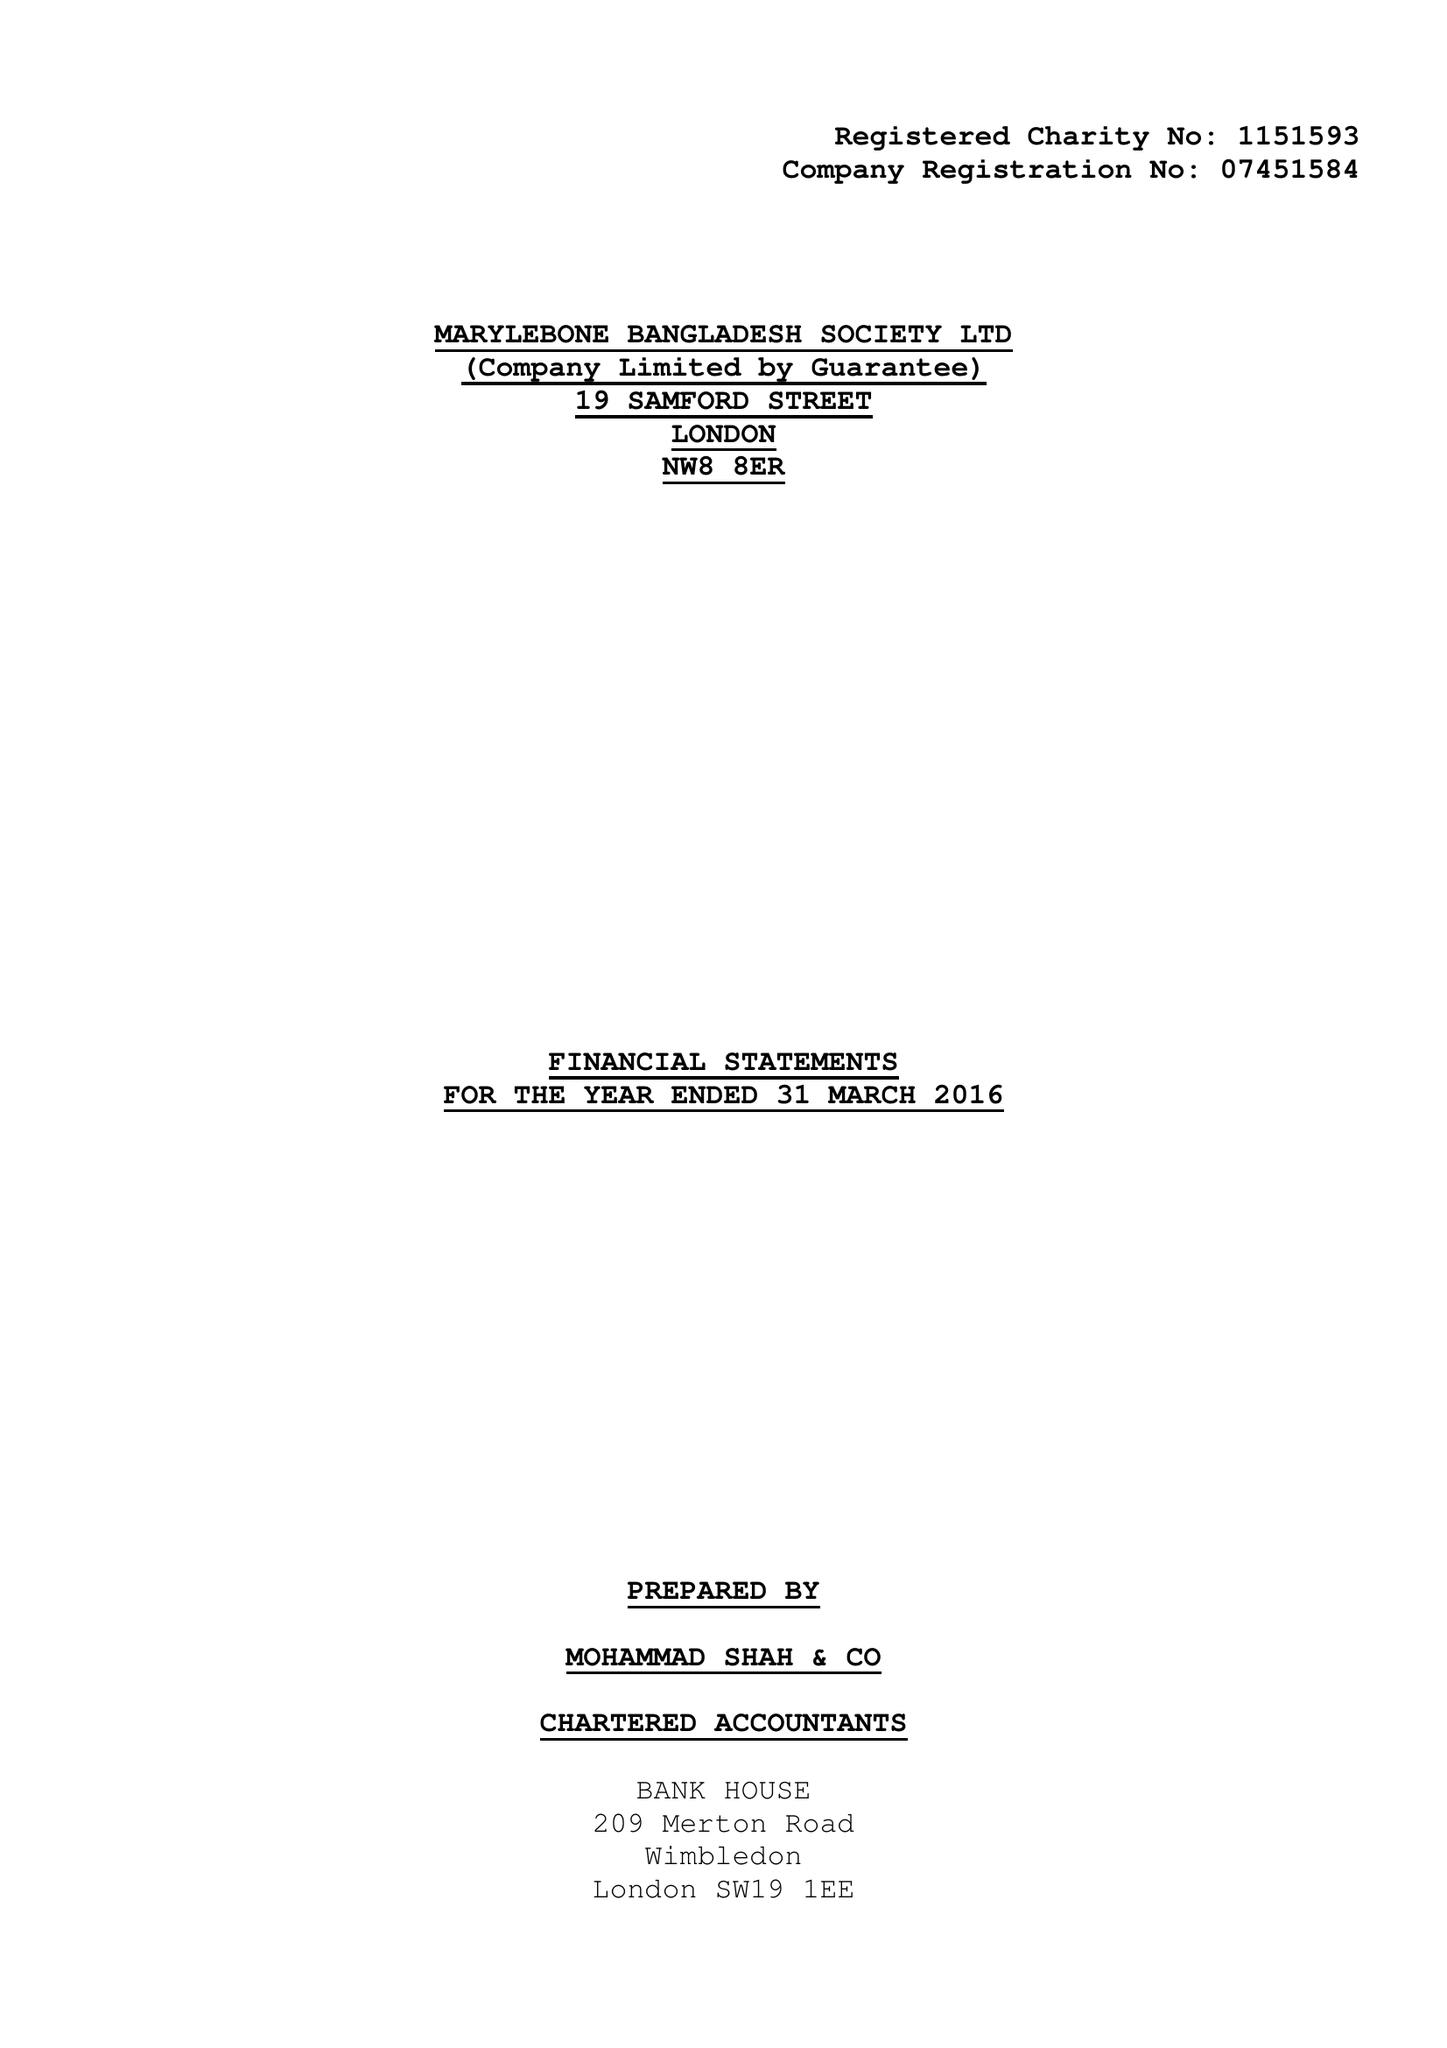What is the value for the spending_annually_in_british_pounds?
Answer the question using a single word or phrase. 169751.00 